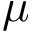Convert formula to latex. <formula><loc_0><loc_0><loc_500><loc_500>\mu</formula> 